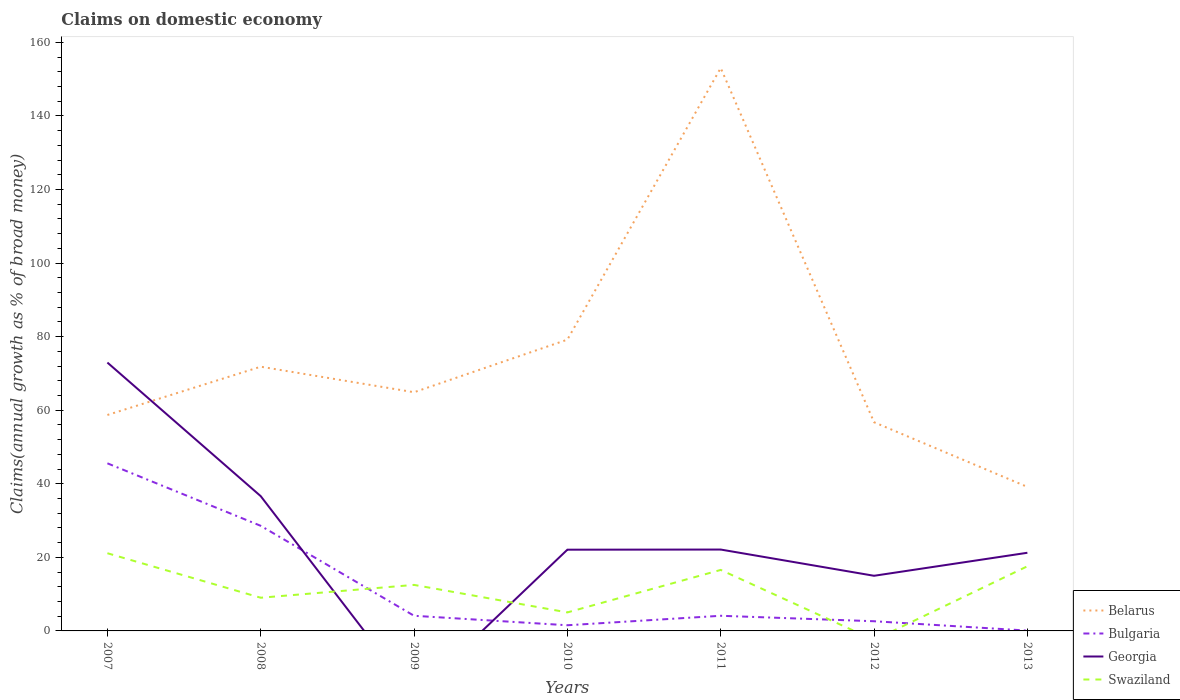Does the line corresponding to Bulgaria intersect with the line corresponding to Georgia?
Your answer should be compact. Yes. Is the number of lines equal to the number of legend labels?
Ensure brevity in your answer.  No. Across all years, what is the maximum percentage of broad money claimed on domestic economy in Bulgaria?
Your answer should be compact. 0.09. What is the total percentage of broad money claimed on domestic economy in Swaziland in the graph?
Ensure brevity in your answer.  -4.07. What is the difference between the highest and the second highest percentage of broad money claimed on domestic economy in Belarus?
Make the answer very short. 113.88. Is the percentage of broad money claimed on domestic economy in Georgia strictly greater than the percentage of broad money claimed on domestic economy in Bulgaria over the years?
Keep it short and to the point. No. How many lines are there?
Provide a succinct answer. 4. What is the difference between two consecutive major ticks on the Y-axis?
Give a very brief answer. 20. Are the values on the major ticks of Y-axis written in scientific E-notation?
Offer a terse response. No. Does the graph contain any zero values?
Offer a terse response. Yes. Does the graph contain grids?
Provide a short and direct response. No. Where does the legend appear in the graph?
Your response must be concise. Bottom right. How are the legend labels stacked?
Your answer should be very brief. Vertical. What is the title of the graph?
Give a very brief answer. Claims on domestic economy. What is the label or title of the Y-axis?
Ensure brevity in your answer.  Claims(annual growth as % of broad money). What is the Claims(annual growth as % of broad money) of Belarus in 2007?
Your answer should be very brief. 58.7. What is the Claims(annual growth as % of broad money) of Bulgaria in 2007?
Offer a very short reply. 45.56. What is the Claims(annual growth as % of broad money) of Georgia in 2007?
Provide a succinct answer. 72.95. What is the Claims(annual growth as % of broad money) of Swaziland in 2007?
Provide a short and direct response. 21.12. What is the Claims(annual growth as % of broad money) of Belarus in 2008?
Ensure brevity in your answer.  71.82. What is the Claims(annual growth as % of broad money) in Bulgaria in 2008?
Your response must be concise. 28.57. What is the Claims(annual growth as % of broad money) in Georgia in 2008?
Give a very brief answer. 36.63. What is the Claims(annual growth as % of broad money) in Swaziland in 2008?
Give a very brief answer. 9.02. What is the Claims(annual growth as % of broad money) of Belarus in 2009?
Your response must be concise. 64.88. What is the Claims(annual growth as % of broad money) in Bulgaria in 2009?
Your answer should be very brief. 4.12. What is the Claims(annual growth as % of broad money) of Swaziland in 2009?
Your response must be concise. 12.51. What is the Claims(annual growth as % of broad money) of Belarus in 2010?
Make the answer very short. 79.17. What is the Claims(annual growth as % of broad money) in Bulgaria in 2010?
Make the answer very short. 1.54. What is the Claims(annual growth as % of broad money) in Georgia in 2010?
Provide a succinct answer. 22.08. What is the Claims(annual growth as % of broad money) of Swaziland in 2010?
Your answer should be compact. 5.03. What is the Claims(annual growth as % of broad money) of Belarus in 2011?
Offer a terse response. 153.03. What is the Claims(annual growth as % of broad money) of Bulgaria in 2011?
Provide a succinct answer. 4.12. What is the Claims(annual growth as % of broad money) in Georgia in 2011?
Provide a short and direct response. 22.12. What is the Claims(annual growth as % of broad money) in Swaziland in 2011?
Give a very brief answer. 16.58. What is the Claims(annual growth as % of broad money) in Belarus in 2012?
Offer a terse response. 56.73. What is the Claims(annual growth as % of broad money) of Bulgaria in 2012?
Ensure brevity in your answer.  2.63. What is the Claims(annual growth as % of broad money) of Georgia in 2012?
Keep it short and to the point. 14.99. What is the Claims(annual growth as % of broad money) of Swaziland in 2012?
Your answer should be compact. 0. What is the Claims(annual growth as % of broad money) in Belarus in 2013?
Your response must be concise. 39.15. What is the Claims(annual growth as % of broad money) in Bulgaria in 2013?
Offer a terse response. 0.09. What is the Claims(annual growth as % of broad money) in Georgia in 2013?
Ensure brevity in your answer.  21.24. What is the Claims(annual growth as % of broad money) of Swaziland in 2013?
Make the answer very short. 17.57. Across all years, what is the maximum Claims(annual growth as % of broad money) in Belarus?
Give a very brief answer. 153.03. Across all years, what is the maximum Claims(annual growth as % of broad money) of Bulgaria?
Ensure brevity in your answer.  45.56. Across all years, what is the maximum Claims(annual growth as % of broad money) in Georgia?
Make the answer very short. 72.95. Across all years, what is the maximum Claims(annual growth as % of broad money) in Swaziland?
Your answer should be very brief. 21.12. Across all years, what is the minimum Claims(annual growth as % of broad money) of Belarus?
Provide a short and direct response. 39.15. Across all years, what is the minimum Claims(annual growth as % of broad money) in Bulgaria?
Offer a terse response. 0.09. What is the total Claims(annual growth as % of broad money) of Belarus in the graph?
Make the answer very short. 523.49. What is the total Claims(annual growth as % of broad money) of Bulgaria in the graph?
Your response must be concise. 86.63. What is the total Claims(annual growth as % of broad money) of Georgia in the graph?
Give a very brief answer. 190.02. What is the total Claims(annual growth as % of broad money) in Swaziland in the graph?
Your answer should be compact. 81.84. What is the difference between the Claims(annual growth as % of broad money) of Belarus in 2007 and that in 2008?
Provide a short and direct response. -13.12. What is the difference between the Claims(annual growth as % of broad money) in Bulgaria in 2007 and that in 2008?
Offer a terse response. 16.99. What is the difference between the Claims(annual growth as % of broad money) in Georgia in 2007 and that in 2008?
Provide a short and direct response. 36.32. What is the difference between the Claims(annual growth as % of broad money) of Swaziland in 2007 and that in 2008?
Provide a short and direct response. 12.1. What is the difference between the Claims(annual growth as % of broad money) in Belarus in 2007 and that in 2009?
Your answer should be very brief. -6.18. What is the difference between the Claims(annual growth as % of broad money) in Bulgaria in 2007 and that in 2009?
Your response must be concise. 41.44. What is the difference between the Claims(annual growth as % of broad money) of Swaziland in 2007 and that in 2009?
Ensure brevity in your answer.  8.61. What is the difference between the Claims(annual growth as % of broad money) of Belarus in 2007 and that in 2010?
Offer a terse response. -20.48. What is the difference between the Claims(annual growth as % of broad money) in Bulgaria in 2007 and that in 2010?
Your response must be concise. 44.02. What is the difference between the Claims(annual growth as % of broad money) in Georgia in 2007 and that in 2010?
Provide a short and direct response. 50.87. What is the difference between the Claims(annual growth as % of broad money) of Swaziland in 2007 and that in 2010?
Your answer should be compact. 16.09. What is the difference between the Claims(annual growth as % of broad money) in Belarus in 2007 and that in 2011?
Make the answer very short. -94.33. What is the difference between the Claims(annual growth as % of broad money) of Bulgaria in 2007 and that in 2011?
Provide a short and direct response. 41.44. What is the difference between the Claims(annual growth as % of broad money) in Georgia in 2007 and that in 2011?
Ensure brevity in your answer.  50.83. What is the difference between the Claims(annual growth as % of broad money) of Swaziland in 2007 and that in 2011?
Keep it short and to the point. 4.54. What is the difference between the Claims(annual growth as % of broad money) of Belarus in 2007 and that in 2012?
Provide a succinct answer. 1.97. What is the difference between the Claims(annual growth as % of broad money) in Bulgaria in 2007 and that in 2012?
Provide a succinct answer. 42.93. What is the difference between the Claims(annual growth as % of broad money) of Georgia in 2007 and that in 2012?
Give a very brief answer. 57.96. What is the difference between the Claims(annual growth as % of broad money) in Belarus in 2007 and that in 2013?
Offer a very short reply. 19.55. What is the difference between the Claims(annual growth as % of broad money) in Bulgaria in 2007 and that in 2013?
Ensure brevity in your answer.  45.47. What is the difference between the Claims(annual growth as % of broad money) of Georgia in 2007 and that in 2013?
Provide a short and direct response. 51.71. What is the difference between the Claims(annual growth as % of broad money) in Swaziland in 2007 and that in 2013?
Keep it short and to the point. 3.55. What is the difference between the Claims(annual growth as % of broad money) in Belarus in 2008 and that in 2009?
Give a very brief answer. 6.94. What is the difference between the Claims(annual growth as % of broad money) in Bulgaria in 2008 and that in 2009?
Make the answer very short. 24.45. What is the difference between the Claims(annual growth as % of broad money) of Swaziland in 2008 and that in 2009?
Keep it short and to the point. -3.49. What is the difference between the Claims(annual growth as % of broad money) in Belarus in 2008 and that in 2010?
Ensure brevity in your answer.  -7.35. What is the difference between the Claims(annual growth as % of broad money) in Bulgaria in 2008 and that in 2010?
Keep it short and to the point. 27.03. What is the difference between the Claims(annual growth as % of broad money) of Georgia in 2008 and that in 2010?
Provide a short and direct response. 14.55. What is the difference between the Claims(annual growth as % of broad money) in Swaziland in 2008 and that in 2010?
Provide a succinct answer. 3.99. What is the difference between the Claims(annual growth as % of broad money) of Belarus in 2008 and that in 2011?
Provide a short and direct response. -81.2. What is the difference between the Claims(annual growth as % of broad money) of Bulgaria in 2008 and that in 2011?
Ensure brevity in your answer.  24.45. What is the difference between the Claims(annual growth as % of broad money) of Georgia in 2008 and that in 2011?
Ensure brevity in your answer.  14.51. What is the difference between the Claims(annual growth as % of broad money) in Swaziland in 2008 and that in 2011?
Give a very brief answer. -7.56. What is the difference between the Claims(annual growth as % of broad money) in Belarus in 2008 and that in 2012?
Make the answer very short. 15.09. What is the difference between the Claims(annual growth as % of broad money) of Bulgaria in 2008 and that in 2012?
Your response must be concise. 25.94. What is the difference between the Claims(annual growth as % of broad money) of Georgia in 2008 and that in 2012?
Keep it short and to the point. 21.65. What is the difference between the Claims(annual growth as % of broad money) in Belarus in 2008 and that in 2013?
Offer a terse response. 32.67. What is the difference between the Claims(annual growth as % of broad money) of Bulgaria in 2008 and that in 2013?
Make the answer very short. 28.48. What is the difference between the Claims(annual growth as % of broad money) in Georgia in 2008 and that in 2013?
Your response must be concise. 15.39. What is the difference between the Claims(annual growth as % of broad money) of Swaziland in 2008 and that in 2013?
Offer a terse response. -8.55. What is the difference between the Claims(annual growth as % of broad money) of Belarus in 2009 and that in 2010?
Give a very brief answer. -14.29. What is the difference between the Claims(annual growth as % of broad money) in Bulgaria in 2009 and that in 2010?
Give a very brief answer. 2.58. What is the difference between the Claims(annual growth as % of broad money) of Swaziland in 2009 and that in 2010?
Ensure brevity in your answer.  7.48. What is the difference between the Claims(annual growth as % of broad money) in Belarus in 2009 and that in 2011?
Keep it short and to the point. -88.14. What is the difference between the Claims(annual growth as % of broad money) in Bulgaria in 2009 and that in 2011?
Offer a terse response. 0. What is the difference between the Claims(annual growth as % of broad money) of Swaziland in 2009 and that in 2011?
Your answer should be very brief. -4.07. What is the difference between the Claims(annual growth as % of broad money) in Belarus in 2009 and that in 2012?
Your answer should be compact. 8.15. What is the difference between the Claims(annual growth as % of broad money) in Bulgaria in 2009 and that in 2012?
Offer a terse response. 1.49. What is the difference between the Claims(annual growth as % of broad money) in Belarus in 2009 and that in 2013?
Keep it short and to the point. 25.73. What is the difference between the Claims(annual growth as % of broad money) of Bulgaria in 2009 and that in 2013?
Your answer should be compact. 4.03. What is the difference between the Claims(annual growth as % of broad money) of Swaziland in 2009 and that in 2013?
Give a very brief answer. -5.06. What is the difference between the Claims(annual growth as % of broad money) in Belarus in 2010 and that in 2011?
Offer a very short reply. -73.85. What is the difference between the Claims(annual growth as % of broad money) in Bulgaria in 2010 and that in 2011?
Provide a succinct answer. -2.58. What is the difference between the Claims(annual growth as % of broad money) in Georgia in 2010 and that in 2011?
Make the answer very short. -0.04. What is the difference between the Claims(annual growth as % of broad money) of Swaziland in 2010 and that in 2011?
Make the answer very short. -11.55. What is the difference between the Claims(annual growth as % of broad money) of Belarus in 2010 and that in 2012?
Provide a short and direct response. 22.44. What is the difference between the Claims(annual growth as % of broad money) of Bulgaria in 2010 and that in 2012?
Give a very brief answer. -1.09. What is the difference between the Claims(annual growth as % of broad money) of Georgia in 2010 and that in 2012?
Offer a terse response. 7.09. What is the difference between the Claims(annual growth as % of broad money) in Belarus in 2010 and that in 2013?
Ensure brevity in your answer.  40.02. What is the difference between the Claims(annual growth as % of broad money) in Bulgaria in 2010 and that in 2013?
Your answer should be compact. 1.45. What is the difference between the Claims(annual growth as % of broad money) of Georgia in 2010 and that in 2013?
Provide a succinct answer. 0.84. What is the difference between the Claims(annual growth as % of broad money) in Swaziland in 2010 and that in 2013?
Offer a terse response. -12.54. What is the difference between the Claims(annual growth as % of broad money) of Belarus in 2011 and that in 2012?
Give a very brief answer. 96.29. What is the difference between the Claims(annual growth as % of broad money) of Bulgaria in 2011 and that in 2012?
Offer a very short reply. 1.49. What is the difference between the Claims(annual growth as % of broad money) of Georgia in 2011 and that in 2012?
Offer a terse response. 7.13. What is the difference between the Claims(annual growth as % of broad money) of Belarus in 2011 and that in 2013?
Your response must be concise. 113.88. What is the difference between the Claims(annual growth as % of broad money) of Bulgaria in 2011 and that in 2013?
Your answer should be compact. 4.03. What is the difference between the Claims(annual growth as % of broad money) in Georgia in 2011 and that in 2013?
Make the answer very short. 0.88. What is the difference between the Claims(annual growth as % of broad money) of Swaziland in 2011 and that in 2013?
Your answer should be very brief. -0.99. What is the difference between the Claims(annual growth as % of broad money) in Belarus in 2012 and that in 2013?
Ensure brevity in your answer.  17.58. What is the difference between the Claims(annual growth as % of broad money) in Bulgaria in 2012 and that in 2013?
Your answer should be compact. 2.54. What is the difference between the Claims(annual growth as % of broad money) in Georgia in 2012 and that in 2013?
Provide a succinct answer. -6.25. What is the difference between the Claims(annual growth as % of broad money) of Belarus in 2007 and the Claims(annual growth as % of broad money) of Bulgaria in 2008?
Provide a succinct answer. 30.13. What is the difference between the Claims(annual growth as % of broad money) in Belarus in 2007 and the Claims(annual growth as % of broad money) in Georgia in 2008?
Your answer should be very brief. 22.06. What is the difference between the Claims(annual growth as % of broad money) of Belarus in 2007 and the Claims(annual growth as % of broad money) of Swaziland in 2008?
Give a very brief answer. 49.68. What is the difference between the Claims(annual growth as % of broad money) in Bulgaria in 2007 and the Claims(annual growth as % of broad money) in Georgia in 2008?
Provide a succinct answer. 8.93. What is the difference between the Claims(annual growth as % of broad money) of Bulgaria in 2007 and the Claims(annual growth as % of broad money) of Swaziland in 2008?
Provide a short and direct response. 36.54. What is the difference between the Claims(annual growth as % of broad money) of Georgia in 2007 and the Claims(annual growth as % of broad money) of Swaziland in 2008?
Ensure brevity in your answer.  63.93. What is the difference between the Claims(annual growth as % of broad money) of Belarus in 2007 and the Claims(annual growth as % of broad money) of Bulgaria in 2009?
Keep it short and to the point. 54.58. What is the difference between the Claims(annual growth as % of broad money) in Belarus in 2007 and the Claims(annual growth as % of broad money) in Swaziland in 2009?
Your answer should be very brief. 46.19. What is the difference between the Claims(annual growth as % of broad money) in Bulgaria in 2007 and the Claims(annual growth as % of broad money) in Swaziland in 2009?
Give a very brief answer. 33.05. What is the difference between the Claims(annual growth as % of broad money) in Georgia in 2007 and the Claims(annual growth as % of broad money) in Swaziland in 2009?
Offer a very short reply. 60.44. What is the difference between the Claims(annual growth as % of broad money) of Belarus in 2007 and the Claims(annual growth as % of broad money) of Bulgaria in 2010?
Provide a succinct answer. 57.16. What is the difference between the Claims(annual growth as % of broad money) in Belarus in 2007 and the Claims(annual growth as % of broad money) in Georgia in 2010?
Provide a succinct answer. 36.62. What is the difference between the Claims(annual growth as % of broad money) in Belarus in 2007 and the Claims(annual growth as % of broad money) in Swaziland in 2010?
Your answer should be very brief. 53.67. What is the difference between the Claims(annual growth as % of broad money) of Bulgaria in 2007 and the Claims(annual growth as % of broad money) of Georgia in 2010?
Your answer should be very brief. 23.48. What is the difference between the Claims(annual growth as % of broad money) of Bulgaria in 2007 and the Claims(annual growth as % of broad money) of Swaziland in 2010?
Your answer should be very brief. 40.53. What is the difference between the Claims(annual growth as % of broad money) of Georgia in 2007 and the Claims(annual growth as % of broad money) of Swaziland in 2010?
Your answer should be very brief. 67.92. What is the difference between the Claims(annual growth as % of broad money) in Belarus in 2007 and the Claims(annual growth as % of broad money) in Bulgaria in 2011?
Offer a terse response. 54.58. What is the difference between the Claims(annual growth as % of broad money) of Belarus in 2007 and the Claims(annual growth as % of broad money) of Georgia in 2011?
Offer a terse response. 36.58. What is the difference between the Claims(annual growth as % of broad money) in Belarus in 2007 and the Claims(annual growth as % of broad money) in Swaziland in 2011?
Make the answer very short. 42.12. What is the difference between the Claims(annual growth as % of broad money) in Bulgaria in 2007 and the Claims(annual growth as % of broad money) in Georgia in 2011?
Your response must be concise. 23.44. What is the difference between the Claims(annual growth as % of broad money) in Bulgaria in 2007 and the Claims(annual growth as % of broad money) in Swaziland in 2011?
Your answer should be compact. 28.98. What is the difference between the Claims(annual growth as % of broad money) of Georgia in 2007 and the Claims(annual growth as % of broad money) of Swaziland in 2011?
Provide a short and direct response. 56.37. What is the difference between the Claims(annual growth as % of broad money) of Belarus in 2007 and the Claims(annual growth as % of broad money) of Bulgaria in 2012?
Ensure brevity in your answer.  56.07. What is the difference between the Claims(annual growth as % of broad money) in Belarus in 2007 and the Claims(annual growth as % of broad money) in Georgia in 2012?
Ensure brevity in your answer.  43.71. What is the difference between the Claims(annual growth as % of broad money) in Bulgaria in 2007 and the Claims(annual growth as % of broad money) in Georgia in 2012?
Provide a short and direct response. 30.57. What is the difference between the Claims(annual growth as % of broad money) in Belarus in 2007 and the Claims(annual growth as % of broad money) in Bulgaria in 2013?
Ensure brevity in your answer.  58.61. What is the difference between the Claims(annual growth as % of broad money) in Belarus in 2007 and the Claims(annual growth as % of broad money) in Georgia in 2013?
Keep it short and to the point. 37.46. What is the difference between the Claims(annual growth as % of broad money) in Belarus in 2007 and the Claims(annual growth as % of broad money) in Swaziland in 2013?
Your answer should be very brief. 41.13. What is the difference between the Claims(annual growth as % of broad money) in Bulgaria in 2007 and the Claims(annual growth as % of broad money) in Georgia in 2013?
Your response must be concise. 24.32. What is the difference between the Claims(annual growth as % of broad money) of Bulgaria in 2007 and the Claims(annual growth as % of broad money) of Swaziland in 2013?
Keep it short and to the point. 27.99. What is the difference between the Claims(annual growth as % of broad money) of Georgia in 2007 and the Claims(annual growth as % of broad money) of Swaziland in 2013?
Offer a very short reply. 55.38. What is the difference between the Claims(annual growth as % of broad money) in Belarus in 2008 and the Claims(annual growth as % of broad money) in Bulgaria in 2009?
Provide a short and direct response. 67.7. What is the difference between the Claims(annual growth as % of broad money) of Belarus in 2008 and the Claims(annual growth as % of broad money) of Swaziland in 2009?
Offer a terse response. 59.31. What is the difference between the Claims(annual growth as % of broad money) in Bulgaria in 2008 and the Claims(annual growth as % of broad money) in Swaziland in 2009?
Offer a very short reply. 16.06. What is the difference between the Claims(annual growth as % of broad money) of Georgia in 2008 and the Claims(annual growth as % of broad money) of Swaziland in 2009?
Offer a terse response. 24.12. What is the difference between the Claims(annual growth as % of broad money) of Belarus in 2008 and the Claims(annual growth as % of broad money) of Bulgaria in 2010?
Your answer should be compact. 70.28. What is the difference between the Claims(annual growth as % of broad money) of Belarus in 2008 and the Claims(annual growth as % of broad money) of Georgia in 2010?
Make the answer very short. 49.74. What is the difference between the Claims(annual growth as % of broad money) in Belarus in 2008 and the Claims(annual growth as % of broad money) in Swaziland in 2010?
Offer a terse response. 66.79. What is the difference between the Claims(annual growth as % of broad money) in Bulgaria in 2008 and the Claims(annual growth as % of broad money) in Georgia in 2010?
Give a very brief answer. 6.49. What is the difference between the Claims(annual growth as % of broad money) of Bulgaria in 2008 and the Claims(annual growth as % of broad money) of Swaziland in 2010?
Offer a very short reply. 23.54. What is the difference between the Claims(annual growth as % of broad money) in Georgia in 2008 and the Claims(annual growth as % of broad money) in Swaziland in 2010?
Provide a succinct answer. 31.6. What is the difference between the Claims(annual growth as % of broad money) in Belarus in 2008 and the Claims(annual growth as % of broad money) in Bulgaria in 2011?
Offer a terse response. 67.7. What is the difference between the Claims(annual growth as % of broad money) in Belarus in 2008 and the Claims(annual growth as % of broad money) in Georgia in 2011?
Keep it short and to the point. 49.7. What is the difference between the Claims(annual growth as % of broad money) in Belarus in 2008 and the Claims(annual growth as % of broad money) in Swaziland in 2011?
Offer a very short reply. 55.24. What is the difference between the Claims(annual growth as % of broad money) of Bulgaria in 2008 and the Claims(annual growth as % of broad money) of Georgia in 2011?
Keep it short and to the point. 6.45. What is the difference between the Claims(annual growth as % of broad money) of Bulgaria in 2008 and the Claims(annual growth as % of broad money) of Swaziland in 2011?
Give a very brief answer. 11.99. What is the difference between the Claims(annual growth as % of broad money) in Georgia in 2008 and the Claims(annual growth as % of broad money) in Swaziland in 2011?
Your answer should be very brief. 20.05. What is the difference between the Claims(annual growth as % of broad money) in Belarus in 2008 and the Claims(annual growth as % of broad money) in Bulgaria in 2012?
Offer a very short reply. 69.19. What is the difference between the Claims(annual growth as % of broad money) in Belarus in 2008 and the Claims(annual growth as % of broad money) in Georgia in 2012?
Keep it short and to the point. 56.83. What is the difference between the Claims(annual growth as % of broad money) in Bulgaria in 2008 and the Claims(annual growth as % of broad money) in Georgia in 2012?
Provide a short and direct response. 13.58. What is the difference between the Claims(annual growth as % of broad money) of Belarus in 2008 and the Claims(annual growth as % of broad money) of Bulgaria in 2013?
Your response must be concise. 71.73. What is the difference between the Claims(annual growth as % of broad money) of Belarus in 2008 and the Claims(annual growth as % of broad money) of Georgia in 2013?
Provide a succinct answer. 50.58. What is the difference between the Claims(annual growth as % of broad money) of Belarus in 2008 and the Claims(annual growth as % of broad money) of Swaziland in 2013?
Provide a short and direct response. 54.25. What is the difference between the Claims(annual growth as % of broad money) of Bulgaria in 2008 and the Claims(annual growth as % of broad money) of Georgia in 2013?
Keep it short and to the point. 7.33. What is the difference between the Claims(annual growth as % of broad money) in Bulgaria in 2008 and the Claims(annual growth as % of broad money) in Swaziland in 2013?
Your answer should be compact. 11. What is the difference between the Claims(annual growth as % of broad money) in Georgia in 2008 and the Claims(annual growth as % of broad money) in Swaziland in 2013?
Give a very brief answer. 19.06. What is the difference between the Claims(annual growth as % of broad money) in Belarus in 2009 and the Claims(annual growth as % of broad money) in Bulgaria in 2010?
Keep it short and to the point. 63.34. What is the difference between the Claims(annual growth as % of broad money) of Belarus in 2009 and the Claims(annual growth as % of broad money) of Georgia in 2010?
Ensure brevity in your answer.  42.8. What is the difference between the Claims(annual growth as % of broad money) in Belarus in 2009 and the Claims(annual growth as % of broad money) in Swaziland in 2010?
Provide a succinct answer. 59.85. What is the difference between the Claims(annual growth as % of broad money) in Bulgaria in 2009 and the Claims(annual growth as % of broad money) in Georgia in 2010?
Your response must be concise. -17.96. What is the difference between the Claims(annual growth as % of broad money) of Bulgaria in 2009 and the Claims(annual growth as % of broad money) of Swaziland in 2010?
Keep it short and to the point. -0.91. What is the difference between the Claims(annual growth as % of broad money) of Belarus in 2009 and the Claims(annual growth as % of broad money) of Bulgaria in 2011?
Offer a terse response. 60.76. What is the difference between the Claims(annual growth as % of broad money) of Belarus in 2009 and the Claims(annual growth as % of broad money) of Georgia in 2011?
Provide a succinct answer. 42.76. What is the difference between the Claims(annual growth as % of broad money) in Belarus in 2009 and the Claims(annual growth as % of broad money) in Swaziland in 2011?
Your answer should be very brief. 48.3. What is the difference between the Claims(annual growth as % of broad money) of Bulgaria in 2009 and the Claims(annual growth as % of broad money) of Georgia in 2011?
Your answer should be compact. -18. What is the difference between the Claims(annual growth as % of broad money) in Bulgaria in 2009 and the Claims(annual growth as % of broad money) in Swaziland in 2011?
Offer a terse response. -12.46. What is the difference between the Claims(annual growth as % of broad money) of Belarus in 2009 and the Claims(annual growth as % of broad money) of Bulgaria in 2012?
Offer a terse response. 62.25. What is the difference between the Claims(annual growth as % of broad money) of Belarus in 2009 and the Claims(annual growth as % of broad money) of Georgia in 2012?
Your answer should be very brief. 49.89. What is the difference between the Claims(annual growth as % of broad money) of Bulgaria in 2009 and the Claims(annual growth as % of broad money) of Georgia in 2012?
Give a very brief answer. -10.87. What is the difference between the Claims(annual growth as % of broad money) in Belarus in 2009 and the Claims(annual growth as % of broad money) in Bulgaria in 2013?
Offer a terse response. 64.79. What is the difference between the Claims(annual growth as % of broad money) in Belarus in 2009 and the Claims(annual growth as % of broad money) in Georgia in 2013?
Your response must be concise. 43.64. What is the difference between the Claims(annual growth as % of broad money) of Belarus in 2009 and the Claims(annual growth as % of broad money) of Swaziland in 2013?
Your answer should be compact. 47.31. What is the difference between the Claims(annual growth as % of broad money) in Bulgaria in 2009 and the Claims(annual growth as % of broad money) in Georgia in 2013?
Give a very brief answer. -17.12. What is the difference between the Claims(annual growth as % of broad money) of Bulgaria in 2009 and the Claims(annual growth as % of broad money) of Swaziland in 2013?
Give a very brief answer. -13.45. What is the difference between the Claims(annual growth as % of broad money) of Belarus in 2010 and the Claims(annual growth as % of broad money) of Bulgaria in 2011?
Offer a terse response. 75.06. What is the difference between the Claims(annual growth as % of broad money) of Belarus in 2010 and the Claims(annual growth as % of broad money) of Georgia in 2011?
Provide a succinct answer. 57.05. What is the difference between the Claims(annual growth as % of broad money) in Belarus in 2010 and the Claims(annual growth as % of broad money) in Swaziland in 2011?
Provide a short and direct response. 62.59. What is the difference between the Claims(annual growth as % of broad money) in Bulgaria in 2010 and the Claims(annual growth as % of broad money) in Georgia in 2011?
Ensure brevity in your answer.  -20.58. What is the difference between the Claims(annual growth as % of broad money) of Bulgaria in 2010 and the Claims(annual growth as % of broad money) of Swaziland in 2011?
Your response must be concise. -15.04. What is the difference between the Claims(annual growth as % of broad money) of Georgia in 2010 and the Claims(annual growth as % of broad money) of Swaziland in 2011?
Your answer should be compact. 5.5. What is the difference between the Claims(annual growth as % of broad money) of Belarus in 2010 and the Claims(annual growth as % of broad money) of Bulgaria in 2012?
Your answer should be compact. 76.54. What is the difference between the Claims(annual growth as % of broad money) in Belarus in 2010 and the Claims(annual growth as % of broad money) in Georgia in 2012?
Keep it short and to the point. 64.19. What is the difference between the Claims(annual growth as % of broad money) in Bulgaria in 2010 and the Claims(annual growth as % of broad money) in Georgia in 2012?
Make the answer very short. -13.45. What is the difference between the Claims(annual growth as % of broad money) in Belarus in 2010 and the Claims(annual growth as % of broad money) in Bulgaria in 2013?
Your response must be concise. 79.09. What is the difference between the Claims(annual growth as % of broad money) in Belarus in 2010 and the Claims(annual growth as % of broad money) in Georgia in 2013?
Give a very brief answer. 57.93. What is the difference between the Claims(annual growth as % of broad money) of Belarus in 2010 and the Claims(annual growth as % of broad money) of Swaziland in 2013?
Your answer should be very brief. 61.6. What is the difference between the Claims(annual growth as % of broad money) of Bulgaria in 2010 and the Claims(annual growth as % of broad money) of Georgia in 2013?
Keep it short and to the point. -19.7. What is the difference between the Claims(annual growth as % of broad money) in Bulgaria in 2010 and the Claims(annual growth as % of broad money) in Swaziland in 2013?
Make the answer very short. -16.03. What is the difference between the Claims(annual growth as % of broad money) in Georgia in 2010 and the Claims(annual growth as % of broad money) in Swaziland in 2013?
Your answer should be compact. 4.51. What is the difference between the Claims(annual growth as % of broad money) of Belarus in 2011 and the Claims(annual growth as % of broad money) of Bulgaria in 2012?
Provide a short and direct response. 150.39. What is the difference between the Claims(annual growth as % of broad money) in Belarus in 2011 and the Claims(annual growth as % of broad money) in Georgia in 2012?
Keep it short and to the point. 138.04. What is the difference between the Claims(annual growth as % of broad money) in Bulgaria in 2011 and the Claims(annual growth as % of broad money) in Georgia in 2012?
Your answer should be compact. -10.87. What is the difference between the Claims(annual growth as % of broad money) of Belarus in 2011 and the Claims(annual growth as % of broad money) of Bulgaria in 2013?
Your answer should be very brief. 152.94. What is the difference between the Claims(annual growth as % of broad money) in Belarus in 2011 and the Claims(annual growth as % of broad money) in Georgia in 2013?
Provide a succinct answer. 131.78. What is the difference between the Claims(annual growth as % of broad money) in Belarus in 2011 and the Claims(annual growth as % of broad money) in Swaziland in 2013?
Offer a terse response. 135.45. What is the difference between the Claims(annual growth as % of broad money) of Bulgaria in 2011 and the Claims(annual growth as % of broad money) of Georgia in 2013?
Ensure brevity in your answer.  -17.13. What is the difference between the Claims(annual growth as % of broad money) of Bulgaria in 2011 and the Claims(annual growth as % of broad money) of Swaziland in 2013?
Provide a succinct answer. -13.45. What is the difference between the Claims(annual growth as % of broad money) of Georgia in 2011 and the Claims(annual growth as % of broad money) of Swaziland in 2013?
Your response must be concise. 4.55. What is the difference between the Claims(annual growth as % of broad money) in Belarus in 2012 and the Claims(annual growth as % of broad money) in Bulgaria in 2013?
Your answer should be very brief. 56.64. What is the difference between the Claims(annual growth as % of broad money) of Belarus in 2012 and the Claims(annual growth as % of broad money) of Georgia in 2013?
Provide a short and direct response. 35.49. What is the difference between the Claims(annual growth as % of broad money) in Belarus in 2012 and the Claims(annual growth as % of broad money) in Swaziland in 2013?
Your answer should be very brief. 39.16. What is the difference between the Claims(annual growth as % of broad money) of Bulgaria in 2012 and the Claims(annual growth as % of broad money) of Georgia in 2013?
Give a very brief answer. -18.61. What is the difference between the Claims(annual growth as % of broad money) of Bulgaria in 2012 and the Claims(annual growth as % of broad money) of Swaziland in 2013?
Offer a terse response. -14.94. What is the difference between the Claims(annual growth as % of broad money) in Georgia in 2012 and the Claims(annual growth as % of broad money) in Swaziland in 2013?
Provide a succinct answer. -2.58. What is the average Claims(annual growth as % of broad money) of Belarus per year?
Provide a short and direct response. 74.78. What is the average Claims(annual growth as % of broad money) of Bulgaria per year?
Keep it short and to the point. 12.38. What is the average Claims(annual growth as % of broad money) in Georgia per year?
Keep it short and to the point. 27.15. What is the average Claims(annual growth as % of broad money) of Swaziland per year?
Your answer should be compact. 11.69. In the year 2007, what is the difference between the Claims(annual growth as % of broad money) in Belarus and Claims(annual growth as % of broad money) in Bulgaria?
Your answer should be very brief. 13.14. In the year 2007, what is the difference between the Claims(annual growth as % of broad money) of Belarus and Claims(annual growth as % of broad money) of Georgia?
Offer a very short reply. -14.25. In the year 2007, what is the difference between the Claims(annual growth as % of broad money) of Belarus and Claims(annual growth as % of broad money) of Swaziland?
Your answer should be compact. 37.58. In the year 2007, what is the difference between the Claims(annual growth as % of broad money) of Bulgaria and Claims(annual growth as % of broad money) of Georgia?
Offer a very short reply. -27.39. In the year 2007, what is the difference between the Claims(annual growth as % of broad money) of Bulgaria and Claims(annual growth as % of broad money) of Swaziland?
Provide a succinct answer. 24.44. In the year 2007, what is the difference between the Claims(annual growth as % of broad money) of Georgia and Claims(annual growth as % of broad money) of Swaziland?
Keep it short and to the point. 51.83. In the year 2008, what is the difference between the Claims(annual growth as % of broad money) of Belarus and Claims(annual growth as % of broad money) of Bulgaria?
Your response must be concise. 43.25. In the year 2008, what is the difference between the Claims(annual growth as % of broad money) in Belarus and Claims(annual growth as % of broad money) in Georgia?
Offer a very short reply. 35.19. In the year 2008, what is the difference between the Claims(annual growth as % of broad money) of Belarus and Claims(annual growth as % of broad money) of Swaziland?
Your response must be concise. 62.8. In the year 2008, what is the difference between the Claims(annual growth as % of broad money) in Bulgaria and Claims(annual growth as % of broad money) in Georgia?
Offer a very short reply. -8.06. In the year 2008, what is the difference between the Claims(annual growth as % of broad money) of Bulgaria and Claims(annual growth as % of broad money) of Swaziland?
Your answer should be compact. 19.55. In the year 2008, what is the difference between the Claims(annual growth as % of broad money) in Georgia and Claims(annual growth as % of broad money) in Swaziland?
Make the answer very short. 27.61. In the year 2009, what is the difference between the Claims(annual growth as % of broad money) of Belarus and Claims(annual growth as % of broad money) of Bulgaria?
Your answer should be compact. 60.76. In the year 2009, what is the difference between the Claims(annual growth as % of broad money) of Belarus and Claims(annual growth as % of broad money) of Swaziland?
Keep it short and to the point. 52.37. In the year 2009, what is the difference between the Claims(annual growth as % of broad money) in Bulgaria and Claims(annual growth as % of broad money) in Swaziland?
Give a very brief answer. -8.39. In the year 2010, what is the difference between the Claims(annual growth as % of broad money) in Belarus and Claims(annual growth as % of broad money) in Bulgaria?
Your response must be concise. 77.63. In the year 2010, what is the difference between the Claims(annual growth as % of broad money) of Belarus and Claims(annual growth as % of broad money) of Georgia?
Offer a very short reply. 57.09. In the year 2010, what is the difference between the Claims(annual growth as % of broad money) in Belarus and Claims(annual growth as % of broad money) in Swaziland?
Provide a short and direct response. 74.14. In the year 2010, what is the difference between the Claims(annual growth as % of broad money) of Bulgaria and Claims(annual growth as % of broad money) of Georgia?
Your answer should be very brief. -20.54. In the year 2010, what is the difference between the Claims(annual growth as % of broad money) of Bulgaria and Claims(annual growth as % of broad money) of Swaziland?
Keep it short and to the point. -3.49. In the year 2010, what is the difference between the Claims(annual growth as % of broad money) of Georgia and Claims(annual growth as % of broad money) of Swaziland?
Make the answer very short. 17.05. In the year 2011, what is the difference between the Claims(annual growth as % of broad money) in Belarus and Claims(annual growth as % of broad money) in Bulgaria?
Give a very brief answer. 148.91. In the year 2011, what is the difference between the Claims(annual growth as % of broad money) in Belarus and Claims(annual growth as % of broad money) in Georgia?
Your answer should be compact. 130.9. In the year 2011, what is the difference between the Claims(annual growth as % of broad money) of Belarus and Claims(annual growth as % of broad money) of Swaziland?
Keep it short and to the point. 136.44. In the year 2011, what is the difference between the Claims(annual growth as % of broad money) of Bulgaria and Claims(annual growth as % of broad money) of Georgia?
Your answer should be very brief. -18. In the year 2011, what is the difference between the Claims(annual growth as % of broad money) in Bulgaria and Claims(annual growth as % of broad money) in Swaziland?
Make the answer very short. -12.46. In the year 2011, what is the difference between the Claims(annual growth as % of broad money) of Georgia and Claims(annual growth as % of broad money) of Swaziland?
Keep it short and to the point. 5.54. In the year 2012, what is the difference between the Claims(annual growth as % of broad money) in Belarus and Claims(annual growth as % of broad money) in Bulgaria?
Provide a short and direct response. 54.1. In the year 2012, what is the difference between the Claims(annual growth as % of broad money) in Belarus and Claims(annual growth as % of broad money) in Georgia?
Provide a succinct answer. 41.74. In the year 2012, what is the difference between the Claims(annual growth as % of broad money) of Bulgaria and Claims(annual growth as % of broad money) of Georgia?
Your answer should be compact. -12.36. In the year 2013, what is the difference between the Claims(annual growth as % of broad money) of Belarus and Claims(annual growth as % of broad money) of Bulgaria?
Provide a short and direct response. 39.06. In the year 2013, what is the difference between the Claims(annual growth as % of broad money) in Belarus and Claims(annual growth as % of broad money) in Georgia?
Provide a succinct answer. 17.91. In the year 2013, what is the difference between the Claims(annual growth as % of broad money) of Belarus and Claims(annual growth as % of broad money) of Swaziland?
Offer a very short reply. 21.58. In the year 2013, what is the difference between the Claims(annual growth as % of broad money) of Bulgaria and Claims(annual growth as % of broad money) of Georgia?
Your response must be concise. -21.15. In the year 2013, what is the difference between the Claims(annual growth as % of broad money) in Bulgaria and Claims(annual growth as % of broad money) in Swaziland?
Your answer should be compact. -17.48. In the year 2013, what is the difference between the Claims(annual growth as % of broad money) in Georgia and Claims(annual growth as % of broad money) in Swaziland?
Provide a short and direct response. 3.67. What is the ratio of the Claims(annual growth as % of broad money) of Belarus in 2007 to that in 2008?
Provide a succinct answer. 0.82. What is the ratio of the Claims(annual growth as % of broad money) in Bulgaria in 2007 to that in 2008?
Make the answer very short. 1.59. What is the ratio of the Claims(annual growth as % of broad money) of Georgia in 2007 to that in 2008?
Offer a terse response. 1.99. What is the ratio of the Claims(annual growth as % of broad money) in Swaziland in 2007 to that in 2008?
Provide a succinct answer. 2.34. What is the ratio of the Claims(annual growth as % of broad money) in Belarus in 2007 to that in 2009?
Offer a terse response. 0.9. What is the ratio of the Claims(annual growth as % of broad money) in Bulgaria in 2007 to that in 2009?
Ensure brevity in your answer.  11.06. What is the ratio of the Claims(annual growth as % of broad money) of Swaziland in 2007 to that in 2009?
Your answer should be compact. 1.69. What is the ratio of the Claims(annual growth as % of broad money) in Belarus in 2007 to that in 2010?
Offer a terse response. 0.74. What is the ratio of the Claims(annual growth as % of broad money) in Bulgaria in 2007 to that in 2010?
Your answer should be very brief. 29.57. What is the ratio of the Claims(annual growth as % of broad money) of Georgia in 2007 to that in 2010?
Offer a very short reply. 3.3. What is the ratio of the Claims(annual growth as % of broad money) of Swaziland in 2007 to that in 2010?
Offer a very short reply. 4.2. What is the ratio of the Claims(annual growth as % of broad money) of Belarus in 2007 to that in 2011?
Offer a terse response. 0.38. What is the ratio of the Claims(annual growth as % of broad money) of Bulgaria in 2007 to that in 2011?
Your answer should be compact. 11.07. What is the ratio of the Claims(annual growth as % of broad money) in Georgia in 2007 to that in 2011?
Your response must be concise. 3.3. What is the ratio of the Claims(annual growth as % of broad money) of Swaziland in 2007 to that in 2011?
Provide a succinct answer. 1.27. What is the ratio of the Claims(annual growth as % of broad money) of Belarus in 2007 to that in 2012?
Ensure brevity in your answer.  1.03. What is the ratio of the Claims(annual growth as % of broad money) of Bulgaria in 2007 to that in 2012?
Provide a short and direct response. 17.31. What is the ratio of the Claims(annual growth as % of broad money) in Georgia in 2007 to that in 2012?
Offer a terse response. 4.87. What is the ratio of the Claims(annual growth as % of broad money) in Belarus in 2007 to that in 2013?
Provide a succinct answer. 1.5. What is the ratio of the Claims(annual growth as % of broad money) in Bulgaria in 2007 to that in 2013?
Make the answer very short. 513.24. What is the ratio of the Claims(annual growth as % of broad money) in Georgia in 2007 to that in 2013?
Provide a succinct answer. 3.43. What is the ratio of the Claims(annual growth as % of broad money) of Swaziland in 2007 to that in 2013?
Your answer should be compact. 1.2. What is the ratio of the Claims(annual growth as % of broad money) in Belarus in 2008 to that in 2009?
Keep it short and to the point. 1.11. What is the ratio of the Claims(annual growth as % of broad money) of Bulgaria in 2008 to that in 2009?
Give a very brief answer. 6.94. What is the ratio of the Claims(annual growth as % of broad money) in Swaziland in 2008 to that in 2009?
Provide a short and direct response. 0.72. What is the ratio of the Claims(annual growth as % of broad money) of Belarus in 2008 to that in 2010?
Give a very brief answer. 0.91. What is the ratio of the Claims(annual growth as % of broad money) in Bulgaria in 2008 to that in 2010?
Keep it short and to the point. 18.55. What is the ratio of the Claims(annual growth as % of broad money) in Georgia in 2008 to that in 2010?
Offer a very short reply. 1.66. What is the ratio of the Claims(annual growth as % of broad money) of Swaziland in 2008 to that in 2010?
Provide a succinct answer. 1.79. What is the ratio of the Claims(annual growth as % of broad money) in Belarus in 2008 to that in 2011?
Ensure brevity in your answer.  0.47. What is the ratio of the Claims(annual growth as % of broad money) in Bulgaria in 2008 to that in 2011?
Your answer should be compact. 6.94. What is the ratio of the Claims(annual growth as % of broad money) of Georgia in 2008 to that in 2011?
Your answer should be very brief. 1.66. What is the ratio of the Claims(annual growth as % of broad money) of Swaziland in 2008 to that in 2011?
Make the answer very short. 0.54. What is the ratio of the Claims(annual growth as % of broad money) of Belarus in 2008 to that in 2012?
Provide a succinct answer. 1.27. What is the ratio of the Claims(annual growth as % of broad money) in Bulgaria in 2008 to that in 2012?
Provide a succinct answer. 10.86. What is the ratio of the Claims(annual growth as % of broad money) in Georgia in 2008 to that in 2012?
Your answer should be compact. 2.44. What is the ratio of the Claims(annual growth as % of broad money) in Belarus in 2008 to that in 2013?
Provide a succinct answer. 1.83. What is the ratio of the Claims(annual growth as % of broad money) in Bulgaria in 2008 to that in 2013?
Ensure brevity in your answer.  321.85. What is the ratio of the Claims(annual growth as % of broad money) of Georgia in 2008 to that in 2013?
Make the answer very short. 1.72. What is the ratio of the Claims(annual growth as % of broad money) of Swaziland in 2008 to that in 2013?
Your answer should be very brief. 0.51. What is the ratio of the Claims(annual growth as % of broad money) in Belarus in 2009 to that in 2010?
Your answer should be very brief. 0.82. What is the ratio of the Claims(annual growth as % of broad money) in Bulgaria in 2009 to that in 2010?
Keep it short and to the point. 2.67. What is the ratio of the Claims(annual growth as % of broad money) in Swaziland in 2009 to that in 2010?
Your answer should be compact. 2.49. What is the ratio of the Claims(annual growth as % of broad money) of Belarus in 2009 to that in 2011?
Keep it short and to the point. 0.42. What is the ratio of the Claims(annual growth as % of broad money) in Swaziland in 2009 to that in 2011?
Offer a terse response. 0.75. What is the ratio of the Claims(annual growth as % of broad money) in Belarus in 2009 to that in 2012?
Provide a succinct answer. 1.14. What is the ratio of the Claims(annual growth as % of broad money) in Bulgaria in 2009 to that in 2012?
Offer a very short reply. 1.57. What is the ratio of the Claims(annual growth as % of broad money) of Belarus in 2009 to that in 2013?
Your response must be concise. 1.66. What is the ratio of the Claims(annual growth as % of broad money) of Bulgaria in 2009 to that in 2013?
Your answer should be very brief. 46.41. What is the ratio of the Claims(annual growth as % of broad money) of Swaziland in 2009 to that in 2013?
Offer a very short reply. 0.71. What is the ratio of the Claims(annual growth as % of broad money) of Belarus in 2010 to that in 2011?
Your response must be concise. 0.52. What is the ratio of the Claims(annual growth as % of broad money) in Bulgaria in 2010 to that in 2011?
Provide a short and direct response. 0.37. What is the ratio of the Claims(annual growth as % of broad money) in Georgia in 2010 to that in 2011?
Your response must be concise. 1. What is the ratio of the Claims(annual growth as % of broad money) of Swaziland in 2010 to that in 2011?
Offer a terse response. 0.3. What is the ratio of the Claims(annual growth as % of broad money) of Belarus in 2010 to that in 2012?
Your answer should be compact. 1.4. What is the ratio of the Claims(annual growth as % of broad money) of Bulgaria in 2010 to that in 2012?
Offer a very short reply. 0.59. What is the ratio of the Claims(annual growth as % of broad money) in Georgia in 2010 to that in 2012?
Your answer should be compact. 1.47. What is the ratio of the Claims(annual growth as % of broad money) of Belarus in 2010 to that in 2013?
Provide a short and direct response. 2.02. What is the ratio of the Claims(annual growth as % of broad money) in Bulgaria in 2010 to that in 2013?
Make the answer very short. 17.35. What is the ratio of the Claims(annual growth as % of broad money) in Georgia in 2010 to that in 2013?
Give a very brief answer. 1.04. What is the ratio of the Claims(annual growth as % of broad money) in Swaziland in 2010 to that in 2013?
Offer a very short reply. 0.29. What is the ratio of the Claims(annual growth as % of broad money) of Belarus in 2011 to that in 2012?
Give a very brief answer. 2.7. What is the ratio of the Claims(annual growth as % of broad money) of Bulgaria in 2011 to that in 2012?
Provide a succinct answer. 1.56. What is the ratio of the Claims(annual growth as % of broad money) of Georgia in 2011 to that in 2012?
Your response must be concise. 1.48. What is the ratio of the Claims(annual growth as % of broad money) in Belarus in 2011 to that in 2013?
Ensure brevity in your answer.  3.91. What is the ratio of the Claims(annual growth as % of broad money) in Bulgaria in 2011 to that in 2013?
Ensure brevity in your answer.  46.38. What is the ratio of the Claims(annual growth as % of broad money) in Georgia in 2011 to that in 2013?
Give a very brief answer. 1.04. What is the ratio of the Claims(annual growth as % of broad money) of Swaziland in 2011 to that in 2013?
Offer a very short reply. 0.94. What is the ratio of the Claims(annual growth as % of broad money) in Belarus in 2012 to that in 2013?
Give a very brief answer. 1.45. What is the ratio of the Claims(annual growth as % of broad money) in Bulgaria in 2012 to that in 2013?
Your answer should be compact. 29.65. What is the ratio of the Claims(annual growth as % of broad money) of Georgia in 2012 to that in 2013?
Offer a very short reply. 0.71. What is the difference between the highest and the second highest Claims(annual growth as % of broad money) in Belarus?
Your response must be concise. 73.85. What is the difference between the highest and the second highest Claims(annual growth as % of broad money) in Bulgaria?
Your response must be concise. 16.99. What is the difference between the highest and the second highest Claims(annual growth as % of broad money) in Georgia?
Your answer should be very brief. 36.32. What is the difference between the highest and the second highest Claims(annual growth as % of broad money) in Swaziland?
Offer a very short reply. 3.55. What is the difference between the highest and the lowest Claims(annual growth as % of broad money) in Belarus?
Offer a very short reply. 113.88. What is the difference between the highest and the lowest Claims(annual growth as % of broad money) of Bulgaria?
Offer a very short reply. 45.47. What is the difference between the highest and the lowest Claims(annual growth as % of broad money) in Georgia?
Keep it short and to the point. 72.95. What is the difference between the highest and the lowest Claims(annual growth as % of broad money) in Swaziland?
Give a very brief answer. 21.12. 